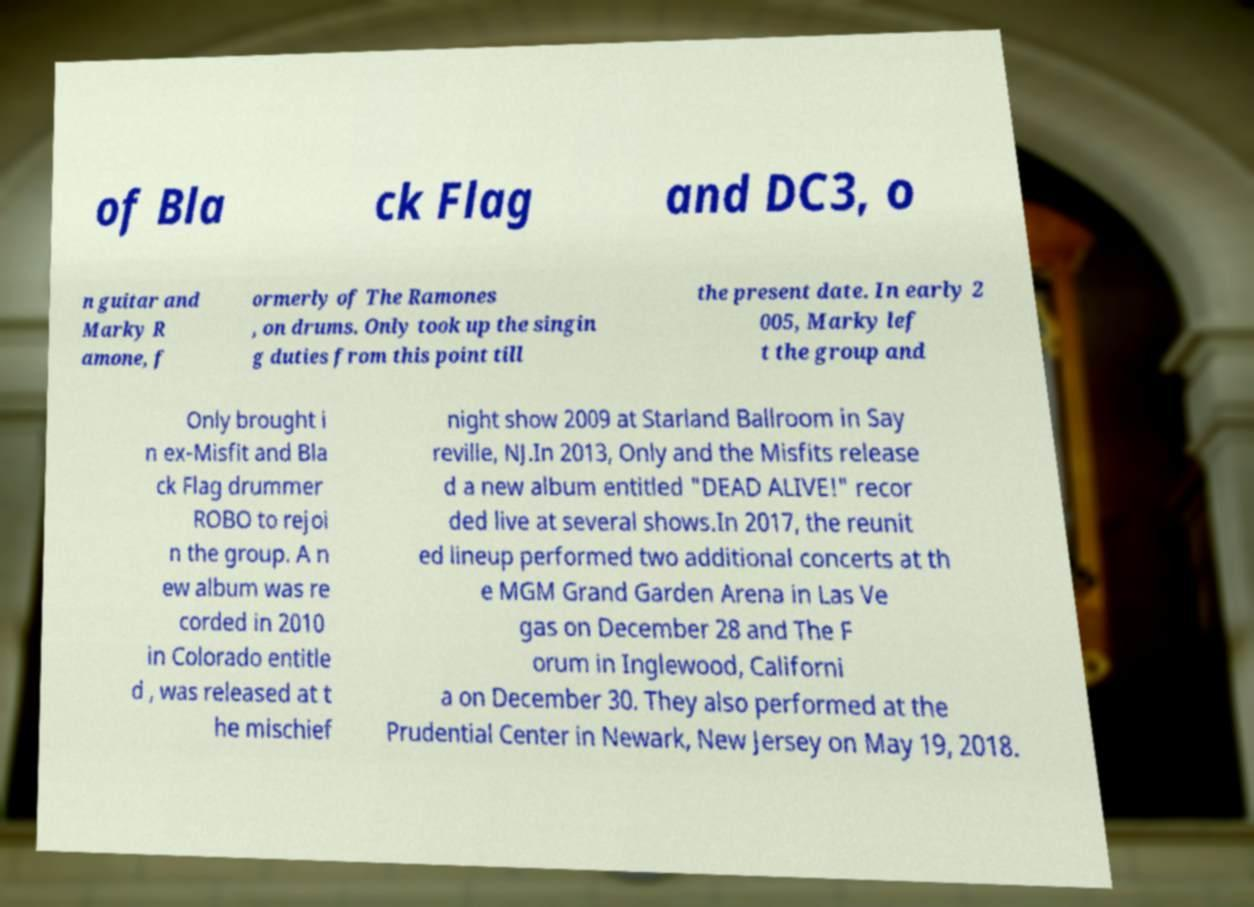There's text embedded in this image that I need extracted. Can you transcribe it verbatim? of Bla ck Flag and DC3, o n guitar and Marky R amone, f ormerly of The Ramones , on drums. Only took up the singin g duties from this point till the present date. In early 2 005, Marky lef t the group and Only brought i n ex-Misfit and Bla ck Flag drummer ROBO to rejoi n the group. A n ew album was re corded in 2010 in Colorado entitle d , was released at t he mischief night show 2009 at Starland Ballroom in Say reville, NJ.In 2013, Only and the Misfits release d a new album entitled "DEAD ALIVE!" recor ded live at several shows.In 2017, the reunit ed lineup performed two additional concerts at th e MGM Grand Garden Arena in Las Ve gas on December 28 and The F orum in Inglewood, Californi a on December 30. They also performed at the Prudential Center in Newark, New Jersey on May 19, 2018. 